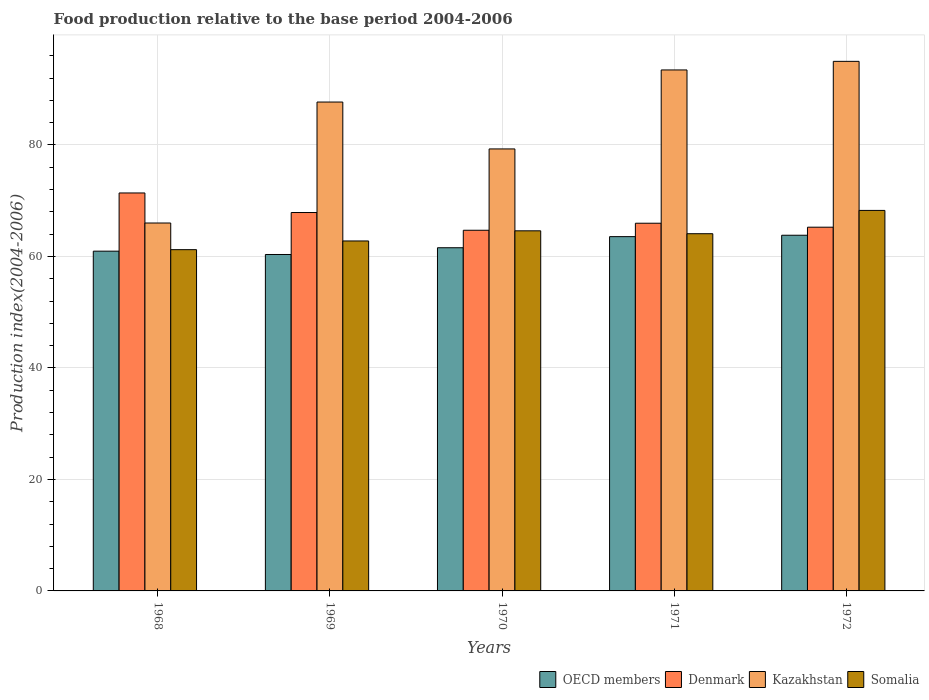How many groups of bars are there?
Offer a very short reply. 5. How many bars are there on the 5th tick from the left?
Offer a terse response. 4. How many bars are there on the 5th tick from the right?
Give a very brief answer. 4. What is the label of the 3rd group of bars from the left?
Your answer should be compact. 1970. In how many cases, is the number of bars for a given year not equal to the number of legend labels?
Make the answer very short. 0. What is the food production index in Somalia in 1970?
Ensure brevity in your answer.  64.6. Across all years, what is the maximum food production index in OECD members?
Ensure brevity in your answer.  63.81. What is the total food production index in OECD members in the graph?
Your response must be concise. 310.23. What is the difference between the food production index in Somalia in 1969 and that in 1970?
Keep it short and to the point. -1.82. What is the difference between the food production index in Denmark in 1968 and the food production index in Kazakhstan in 1972?
Offer a terse response. -23.61. What is the average food production index in Kazakhstan per year?
Give a very brief answer. 84.29. In the year 1968, what is the difference between the food production index in Kazakhstan and food production index in Somalia?
Ensure brevity in your answer.  4.78. In how many years, is the food production index in Somalia greater than 60?
Offer a terse response. 5. What is the ratio of the food production index in Somalia in 1969 to that in 1972?
Offer a terse response. 0.92. Is the difference between the food production index in Kazakhstan in 1969 and 1970 greater than the difference between the food production index in Somalia in 1969 and 1970?
Give a very brief answer. Yes. What is the difference between the highest and the second highest food production index in Kazakhstan?
Keep it short and to the point. 1.54. What is the difference between the highest and the lowest food production index in Somalia?
Your answer should be very brief. 7.04. In how many years, is the food production index in Denmark greater than the average food production index in Denmark taken over all years?
Offer a very short reply. 2. Is the sum of the food production index in Somalia in 1969 and 1970 greater than the maximum food production index in OECD members across all years?
Ensure brevity in your answer.  Yes. Is it the case that in every year, the sum of the food production index in Denmark and food production index in OECD members is greater than the sum of food production index in Somalia and food production index in Kazakhstan?
Offer a very short reply. No. What does the 3rd bar from the left in 1972 represents?
Your answer should be compact. Kazakhstan. What does the 2nd bar from the right in 1971 represents?
Your answer should be very brief. Kazakhstan. How many bars are there?
Ensure brevity in your answer.  20. Are all the bars in the graph horizontal?
Offer a terse response. No. What is the difference between two consecutive major ticks on the Y-axis?
Give a very brief answer. 20. Does the graph contain any zero values?
Your response must be concise. No. Does the graph contain grids?
Provide a succinct answer. Yes. How are the legend labels stacked?
Provide a short and direct response. Horizontal. What is the title of the graph?
Make the answer very short. Food production relative to the base period 2004-2006. Does "Isle of Man" appear as one of the legend labels in the graph?
Make the answer very short. No. What is the label or title of the Y-axis?
Offer a terse response. Production index(2004-2006). What is the Production index(2004-2006) in OECD members in 1968?
Give a very brief answer. 60.95. What is the Production index(2004-2006) in Denmark in 1968?
Provide a succinct answer. 71.39. What is the Production index(2004-2006) in Kazakhstan in 1968?
Your response must be concise. 66. What is the Production index(2004-2006) in Somalia in 1968?
Make the answer very short. 61.22. What is the Production index(2004-2006) in OECD members in 1969?
Give a very brief answer. 60.35. What is the Production index(2004-2006) in Denmark in 1969?
Provide a succinct answer. 67.88. What is the Production index(2004-2006) of Kazakhstan in 1969?
Offer a very short reply. 87.7. What is the Production index(2004-2006) of Somalia in 1969?
Keep it short and to the point. 62.78. What is the Production index(2004-2006) of OECD members in 1970?
Offer a very short reply. 61.56. What is the Production index(2004-2006) of Denmark in 1970?
Keep it short and to the point. 64.7. What is the Production index(2004-2006) in Kazakhstan in 1970?
Keep it short and to the point. 79.29. What is the Production index(2004-2006) in Somalia in 1970?
Make the answer very short. 64.6. What is the Production index(2004-2006) of OECD members in 1971?
Your answer should be very brief. 63.56. What is the Production index(2004-2006) in Denmark in 1971?
Your response must be concise. 65.96. What is the Production index(2004-2006) of Kazakhstan in 1971?
Provide a succinct answer. 93.46. What is the Production index(2004-2006) of Somalia in 1971?
Keep it short and to the point. 64.08. What is the Production index(2004-2006) in OECD members in 1972?
Offer a terse response. 63.81. What is the Production index(2004-2006) in Denmark in 1972?
Provide a succinct answer. 65.25. What is the Production index(2004-2006) in Somalia in 1972?
Offer a terse response. 68.26. Across all years, what is the maximum Production index(2004-2006) in OECD members?
Ensure brevity in your answer.  63.81. Across all years, what is the maximum Production index(2004-2006) in Denmark?
Give a very brief answer. 71.39. Across all years, what is the maximum Production index(2004-2006) in Kazakhstan?
Your answer should be compact. 95. Across all years, what is the maximum Production index(2004-2006) in Somalia?
Your response must be concise. 68.26. Across all years, what is the minimum Production index(2004-2006) of OECD members?
Your answer should be very brief. 60.35. Across all years, what is the minimum Production index(2004-2006) in Denmark?
Give a very brief answer. 64.7. Across all years, what is the minimum Production index(2004-2006) in Somalia?
Ensure brevity in your answer.  61.22. What is the total Production index(2004-2006) of OECD members in the graph?
Your response must be concise. 310.23. What is the total Production index(2004-2006) in Denmark in the graph?
Provide a succinct answer. 335.18. What is the total Production index(2004-2006) in Kazakhstan in the graph?
Your answer should be very brief. 421.45. What is the total Production index(2004-2006) in Somalia in the graph?
Ensure brevity in your answer.  320.94. What is the difference between the Production index(2004-2006) in OECD members in 1968 and that in 1969?
Give a very brief answer. 0.6. What is the difference between the Production index(2004-2006) in Denmark in 1968 and that in 1969?
Offer a terse response. 3.51. What is the difference between the Production index(2004-2006) of Kazakhstan in 1968 and that in 1969?
Provide a succinct answer. -21.7. What is the difference between the Production index(2004-2006) of Somalia in 1968 and that in 1969?
Keep it short and to the point. -1.56. What is the difference between the Production index(2004-2006) of OECD members in 1968 and that in 1970?
Provide a succinct answer. -0.61. What is the difference between the Production index(2004-2006) in Denmark in 1968 and that in 1970?
Give a very brief answer. 6.69. What is the difference between the Production index(2004-2006) in Kazakhstan in 1968 and that in 1970?
Offer a terse response. -13.29. What is the difference between the Production index(2004-2006) of Somalia in 1968 and that in 1970?
Provide a succinct answer. -3.38. What is the difference between the Production index(2004-2006) of OECD members in 1968 and that in 1971?
Your answer should be compact. -2.61. What is the difference between the Production index(2004-2006) in Denmark in 1968 and that in 1971?
Your answer should be very brief. 5.43. What is the difference between the Production index(2004-2006) of Kazakhstan in 1968 and that in 1971?
Provide a short and direct response. -27.46. What is the difference between the Production index(2004-2006) of Somalia in 1968 and that in 1971?
Your answer should be compact. -2.86. What is the difference between the Production index(2004-2006) of OECD members in 1968 and that in 1972?
Make the answer very short. -2.86. What is the difference between the Production index(2004-2006) in Denmark in 1968 and that in 1972?
Your response must be concise. 6.14. What is the difference between the Production index(2004-2006) in Somalia in 1968 and that in 1972?
Make the answer very short. -7.04. What is the difference between the Production index(2004-2006) in OECD members in 1969 and that in 1970?
Offer a very short reply. -1.21. What is the difference between the Production index(2004-2006) of Denmark in 1969 and that in 1970?
Your answer should be compact. 3.18. What is the difference between the Production index(2004-2006) in Kazakhstan in 1969 and that in 1970?
Your response must be concise. 8.41. What is the difference between the Production index(2004-2006) of Somalia in 1969 and that in 1970?
Your answer should be compact. -1.82. What is the difference between the Production index(2004-2006) of OECD members in 1969 and that in 1971?
Give a very brief answer. -3.2. What is the difference between the Production index(2004-2006) of Denmark in 1969 and that in 1971?
Ensure brevity in your answer.  1.92. What is the difference between the Production index(2004-2006) in Kazakhstan in 1969 and that in 1971?
Your answer should be compact. -5.76. What is the difference between the Production index(2004-2006) of OECD members in 1969 and that in 1972?
Provide a short and direct response. -3.45. What is the difference between the Production index(2004-2006) in Denmark in 1969 and that in 1972?
Give a very brief answer. 2.63. What is the difference between the Production index(2004-2006) in Somalia in 1969 and that in 1972?
Keep it short and to the point. -5.48. What is the difference between the Production index(2004-2006) of OECD members in 1970 and that in 1971?
Keep it short and to the point. -1.99. What is the difference between the Production index(2004-2006) in Denmark in 1970 and that in 1971?
Provide a succinct answer. -1.26. What is the difference between the Production index(2004-2006) in Kazakhstan in 1970 and that in 1971?
Keep it short and to the point. -14.17. What is the difference between the Production index(2004-2006) of Somalia in 1970 and that in 1971?
Keep it short and to the point. 0.52. What is the difference between the Production index(2004-2006) in OECD members in 1970 and that in 1972?
Your answer should be compact. -2.24. What is the difference between the Production index(2004-2006) of Denmark in 1970 and that in 1972?
Make the answer very short. -0.55. What is the difference between the Production index(2004-2006) in Kazakhstan in 1970 and that in 1972?
Offer a very short reply. -15.71. What is the difference between the Production index(2004-2006) in Somalia in 1970 and that in 1972?
Make the answer very short. -3.66. What is the difference between the Production index(2004-2006) in OECD members in 1971 and that in 1972?
Provide a short and direct response. -0.25. What is the difference between the Production index(2004-2006) of Denmark in 1971 and that in 1972?
Make the answer very short. 0.71. What is the difference between the Production index(2004-2006) in Kazakhstan in 1971 and that in 1972?
Offer a terse response. -1.54. What is the difference between the Production index(2004-2006) in Somalia in 1971 and that in 1972?
Your response must be concise. -4.18. What is the difference between the Production index(2004-2006) in OECD members in 1968 and the Production index(2004-2006) in Denmark in 1969?
Ensure brevity in your answer.  -6.93. What is the difference between the Production index(2004-2006) in OECD members in 1968 and the Production index(2004-2006) in Kazakhstan in 1969?
Provide a short and direct response. -26.75. What is the difference between the Production index(2004-2006) of OECD members in 1968 and the Production index(2004-2006) of Somalia in 1969?
Your response must be concise. -1.83. What is the difference between the Production index(2004-2006) of Denmark in 1968 and the Production index(2004-2006) of Kazakhstan in 1969?
Provide a short and direct response. -16.31. What is the difference between the Production index(2004-2006) of Denmark in 1968 and the Production index(2004-2006) of Somalia in 1969?
Your response must be concise. 8.61. What is the difference between the Production index(2004-2006) in Kazakhstan in 1968 and the Production index(2004-2006) in Somalia in 1969?
Give a very brief answer. 3.22. What is the difference between the Production index(2004-2006) in OECD members in 1968 and the Production index(2004-2006) in Denmark in 1970?
Your answer should be compact. -3.75. What is the difference between the Production index(2004-2006) in OECD members in 1968 and the Production index(2004-2006) in Kazakhstan in 1970?
Keep it short and to the point. -18.34. What is the difference between the Production index(2004-2006) of OECD members in 1968 and the Production index(2004-2006) of Somalia in 1970?
Offer a terse response. -3.65. What is the difference between the Production index(2004-2006) in Denmark in 1968 and the Production index(2004-2006) in Kazakhstan in 1970?
Give a very brief answer. -7.9. What is the difference between the Production index(2004-2006) in Denmark in 1968 and the Production index(2004-2006) in Somalia in 1970?
Your response must be concise. 6.79. What is the difference between the Production index(2004-2006) in Kazakhstan in 1968 and the Production index(2004-2006) in Somalia in 1970?
Offer a very short reply. 1.4. What is the difference between the Production index(2004-2006) in OECD members in 1968 and the Production index(2004-2006) in Denmark in 1971?
Your answer should be compact. -5.01. What is the difference between the Production index(2004-2006) in OECD members in 1968 and the Production index(2004-2006) in Kazakhstan in 1971?
Ensure brevity in your answer.  -32.51. What is the difference between the Production index(2004-2006) in OECD members in 1968 and the Production index(2004-2006) in Somalia in 1971?
Ensure brevity in your answer.  -3.13. What is the difference between the Production index(2004-2006) in Denmark in 1968 and the Production index(2004-2006) in Kazakhstan in 1971?
Give a very brief answer. -22.07. What is the difference between the Production index(2004-2006) in Denmark in 1968 and the Production index(2004-2006) in Somalia in 1971?
Offer a terse response. 7.31. What is the difference between the Production index(2004-2006) of Kazakhstan in 1968 and the Production index(2004-2006) of Somalia in 1971?
Offer a very short reply. 1.92. What is the difference between the Production index(2004-2006) in OECD members in 1968 and the Production index(2004-2006) in Denmark in 1972?
Your answer should be compact. -4.3. What is the difference between the Production index(2004-2006) of OECD members in 1968 and the Production index(2004-2006) of Kazakhstan in 1972?
Your response must be concise. -34.05. What is the difference between the Production index(2004-2006) of OECD members in 1968 and the Production index(2004-2006) of Somalia in 1972?
Keep it short and to the point. -7.31. What is the difference between the Production index(2004-2006) in Denmark in 1968 and the Production index(2004-2006) in Kazakhstan in 1972?
Offer a terse response. -23.61. What is the difference between the Production index(2004-2006) in Denmark in 1968 and the Production index(2004-2006) in Somalia in 1972?
Provide a succinct answer. 3.13. What is the difference between the Production index(2004-2006) of Kazakhstan in 1968 and the Production index(2004-2006) of Somalia in 1972?
Offer a terse response. -2.26. What is the difference between the Production index(2004-2006) in OECD members in 1969 and the Production index(2004-2006) in Denmark in 1970?
Offer a very short reply. -4.35. What is the difference between the Production index(2004-2006) in OECD members in 1969 and the Production index(2004-2006) in Kazakhstan in 1970?
Your answer should be compact. -18.94. What is the difference between the Production index(2004-2006) of OECD members in 1969 and the Production index(2004-2006) of Somalia in 1970?
Offer a very short reply. -4.25. What is the difference between the Production index(2004-2006) in Denmark in 1969 and the Production index(2004-2006) in Kazakhstan in 1970?
Offer a terse response. -11.41. What is the difference between the Production index(2004-2006) in Denmark in 1969 and the Production index(2004-2006) in Somalia in 1970?
Offer a terse response. 3.28. What is the difference between the Production index(2004-2006) of Kazakhstan in 1969 and the Production index(2004-2006) of Somalia in 1970?
Ensure brevity in your answer.  23.1. What is the difference between the Production index(2004-2006) of OECD members in 1969 and the Production index(2004-2006) of Denmark in 1971?
Keep it short and to the point. -5.61. What is the difference between the Production index(2004-2006) of OECD members in 1969 and the Production index(2004-2006) of Kazakhstan in 1971?
Provide a succinct answer. -33.11. What is the difference between the Production index(2004-2006) in OECD members in 1969 and the Production index(2004-2006) in Somalia in 1971?
Your answer should be compact. -3.73. What is the difference between the Production index(2004-2006) of Denmark in 1969 and the Production index(2004-2006) of Kazakhstan in 1971?
Provide a succinct answer. -25.58. What is the difference between the Production index(2004-2006) of Denmark in 1969 and the Production index(2004-2006) of Somalia in 1971?
Keep it short and to the point. 3.8. What is the difference between the Production index(2004-2006) of Kazakhstan in 1969 and the Production index(2004-2006) of Somalia in 1971?
Provide a short and direct response. 23.62. What is the difference between the Production index(2004-2006) in OECD members in 1969 and the Production index(2004-2006) in Denmark in 1972?
Keep it short and to the point. -4.9. What is the difference between the Production index(2004-2006) of OECD members in 1969 and the Production index(2004-2006) of Kazakhstan in 1972?
Your answer should be very brief. -34.65. What is the difference between the Production index(2004-2006) in OECD members in 1969 and the Production index(2004-2006) in Somalia in 1972?
Your answer should be compact. -7.91. What is the difference between the Production index(2004-2006) of Denmark in 1969 and the Production index(2004-2006) of Kazakhstan in 1972?
Your response must be concise. -27.12. What is the difference between the Production index(2004-2006) of Denmark in 1969 and the Production index(2004-2006) of Somalia in 1972?
Make the answer very short. -0.38. What is the difference between the Production index(2004-2006) of Kazakhstan in 1969 and the Production index(2004-2006) of Somalia in 1972?
Keep it short and to the point. 19.44. What is the difference between the Production index(2004-2006) of OECD members in 1970 and the Production index(2004-2006) of Denmark in 1971?
Your answer should be compact. -4.4. What is the difference between the Production index(2004-2006) in OECD members in 1970 and the Production index(2004-2006) in Kazakhstan in 1971?
Ensure brevity in your answer.  -31.9. What is the difference between the Production index(2004-2006) in OECD members in 1970 and the Production index(2004-2006) in Somalia in 1971?
Your response must be concise. -2.52. What is the difference between the Production index(2004-2006) in Denmark in 1970 and the Production index(2004-2006) in Kazakhstan in 1971?
Give a very brief answer. -28.76. What is the difference between the Production index(2004-2006) in Denmark in 1970 and the Production index(2004-2006) in Somalia in 1971?
Your answer should be very brief. 0.62. What is the difference between the Production index(2004-2006) in Kazakhstan in 1970 and the Production index(2004-2006) in Somalia in 1971?
Make the answer very short. 15.21. What is the difference between the Production index(2004-2006) of OECD members in 1970 and the Production index(2004-2006) of Denmark in 1972?
Offer a terse response. -3.69. What is the difference between the Production index(2004-2006) in OECD members in 1970 and the Production index(2004-2006) in Kazakhstan in 1972?
Provide a succinct answer. -33.44. What is the difference between the Production index(2004-2006) in OECD members in 1970 and the Production index(2004-2006) in Somalia in 1972?
Your answer should be very brief. -6.7. What is the difference between the Production index(2004-2006) of Denmark in 1970 and the Production index(2004-2006) of Kazakhstan in 1972?
Make the answer very short. -30.3. What is the difference between the Production index(2004-2006) of Denmark in 1970 and the Production index(2004-2006) of Somalia in 1972?
Your answer should be compact. -3.56. What is the difference between the Production index(2004-2006) in Kazakhstan in 1970 and the Production index(2004-2006) in Somalia in 1972?
Make the answer very short. 11.03. What is the difference between the Production index(2004-2006) in OECD members in 1971 and the Production index(2004-2006) in Denmark in 1972?
Keep it short and to the point. -1.69. What is the difference between the Production index(2004-2006) in OECD members in 1971 and the Production index(2004-2006) in Kazakhstan in 1972?
Your answer should be compact. -31.44. What is the difference between the Production index(2004-2006) in OECD members in 1971 and the Production index(2004-2006) in Somalia in 1972?
Keep it short and to the point. -4.7. What is the difference between the Production index(2004-2006) in Denmark in 1971 and the Production index(2004-2006) in Kazakhstan in 1972?
Your answer should be compact. -29.04. What is the difference between the Production index(2004-2006) in Denmark in 1971 and the Production index(2004-2006) in Somalia in 1972?
Your answer should be very brief. -2.3. What is the difference between the Production index(2004-2006) of Kazakhstan in 1971 and the Production index(2004-2006) of Somalia in 1972?
Your response must be concise. 25.2. What is the average Production index(2004-2006) in OECD members per year?
Provide a succinct answer. 62.05. What is the average Production index(2004-2006) of Denmark per year?
Offer a terse response. 67.04. What is the average Production index(2004-2006) in Kazakhstan per year?
Your answer should be very brief. 84.29. What is the average Production index(2004-2006) in Somalia per year?
Your response must be concise. 64.19. In the year 1968, what is the difference between the Production index(2004-2006) in OECD members and Production index(2004-2006) in Denmark?
Your answer should be compact. -10.44. In the year 1968, what is the difference between the Production index(2004-2006) in OECD members and Production index(2004-2006) in Kazakhstan?
Give a very brief answer. -5.05. In the year 1968, what is the difference between the Production index(2004-2006) of OECD members and Production index(2004-2006) of Somalia?
Your response must be concise. -0.27. In the year 1968, what is the difference between the Production index(2004-2006) in Denmark and Production index(2004-2006) in Kazakhstan?
Make the answer very short. 5.39. In the year 1968, what is the difference between the Production index(2004-2006) of Denmark and Production index(2004-2006) of Somalia?
Give a very brief answer. 10.17. In the year 1968, what is the difference between the Production index(2004-2006) of Kazakhstan and Production index(2004-2006) of Somalia?
Make the answer very short. 4.78. In the year 1969, what is the difference between the Production index(2004-2006) in OECD members and Production index(2004-2006) in Denmark?
Provide a short and direct response. -7.53. In the year 1969, what is the difference between the Production index(2004-2006) of OECD members and Production index(2004-2006) of Kazakhstan?
Keep it short and to the point. -27.35. In the year 1969, what is the difference between the Production index(2004-2006) of OECD members and Production index(2004-2006) of Somalia?
Your response must be concise. -2.43. In the year 1969, what is the difference between the Production index(2004-2006) of Denmark and Production index(2004-2006) of Kazakhstan?
Keep it short and to the point. -19.82. In the year 1969, what is the difference between the Production index(2004-2006) in Denmark and Production index(2004-2006) in Somalia?
Ensure brevity in your answer.  5.1. In the year 1969, what is the difference between the Production index(2004-2006) of Kazakhstan and Production index(2004-2006) of Somalia?
Your answer should be compact. 24.92. In the year 1970, what is the difference between the Production index(2004-2006) of OECD members and Production index(2004-2006) of Denmark?
Provide a short and direct response. -3.14. In the year 1970, what is the difference between the Production index(2004-2006) in OECD members and Production index(2004-2006) in Kazakhstan?
Your response must be concise. -17.73. In the year 1970, what is the difference between the Production index(2004-2006) in OECD members and Production index(2004-2006) in Somalia?
Your response must be concise. -3.04. In the year 1970, what is the difference between the Production index(2004-2006) of Denmark and Production index(2004-2006) of Kazakhstan?
Make the answer very short. -14.59. In the year 1970, what is the difference between the Production index(2004-2006) in Kazakhstan and Production index(2004-2006) in Somalia?
Ensure brevity in your answer.  14.69. In the year 1971, what is the difference between the Production index(2004-2006) of OECD members and Production index(2004-2006) of Denmark?
Make the answer very short. -2.4. In the year 1971, what is the difference between the Production index(2004-2006) in OECD members and Production index(2004-2006) in Kazakhstan?
Offer a very short reply. -29.9. In the year 1971, what is the difference between the Production index(2004-2006) in OECD members and Production index(2004-2006) in Somalia?
Give a very brief answer. -0.52. In the year 1971, what is the difference between the Production index(2004-2006) in Denmark and Production index(2004-2006) in Kazakhstan?
Provide a short and direct response. -27.5. In the year 1971, what is the difference between the Production index(2004-2006) in Denmark and Production index(2004-2006) in Somalia?
Your response must be concise. 1.88. In the year 1971, what is the difference between the Production index(2004-2006) of Kazakhstan and Production index(2004-2006) of Somalia?
Ensure brevity in your answer.  29.38. In the year 1972, what is the difference between the Production index(2004-2006) of OECD members and Production index(2004-2006) of Denmark?
Provide a short and direct response. -1.44. In the year 1972, what is the difference between the Production index(2004-2006) of OECD members and Production index(2004-2006) of Kazakhstan?
Provide a succinct answer. -31.19. In the year 1972, what is the difference between the Production index(2004-2006) of OECD members and Production index(2004-2006) of Somalia?
Make the answer very short. -4.45. In the year 1972, what is the difference between the Production index(2004-2006) of Denmark and Production index(2004-2006) of Kazakhstan?
Your response must be concise. -29.75. In the year 1972, what is the difference between the Production index(2004-2006) in Denmark and Production index(2004-2006) in Somalia?
Your answer should be very brief. -3.01. In the year 1972, what is the difference between the Production index(2004-2006) of Kazakhstan and Production index(2004-2006) of Somalia?
Your response must be concise. 26.74. What is the ratio of the Production index(2004-2006) in OECD members in 1968 to that in 1969?
Provide a short and direct response. 1.01. What is the ratio of the Production index(2004-2006) of Denmark in 1968 to that in 1969?
Make the answer very short. 1.05. What is the ratio of the Production index(2004-2006) in Kazakhstan in 1968 to that in 1969?
Your answer should be compact. 0.75. What is the ratio of the Production index(2004-2006) in Somalia in 1968 to that in 1969?
Ensure brevity in your answer.  0.98. What is the ratio of the Production index(2004-2006) in Denmark in 1968 to that in 1970?
Make the answer very short. 1.1. What is the ratio of the Production index(2004-2006) in Kazakhstan in 1968 to that in 1970?
Provide a short and direct response. 0.83. What is the ratio of the Production index(2004-2006) in Somalia in 1968 to that in 1970?
Your answer should be very brief. 0.95. What is the ratio of the Production index(2004-2006) in Denmark in 1968 to that in 1971?
Provide a succinct answer. 1.08. What is the ratio of the Production index(2004-2006) in Kazakhstan in 1968 to that in 1971?
Make the answer very short. 0.71. What is the ratio of the Production index(2004-2006) in Somalia in 1968 to that in 1971?
Provide a short and direct response. 0.96. What is the ratio of the Production index(2004-2006) in OECD members in 1968 to that in 1972?
Make the answer very short. 0.96. What is the ratio of the Production index(2004-2006) in Denmark in 1968 to that in 1972?
Your answer should be very brief. 1.09. What is the ratio of the Production index(2004-2006) in Kazakhstan in 1968 to that in 1972?
Offer a terse response. 0.69. What is the ratio of the Production index(2004-2006) of Somalia in 1968 to that in 1972?
Provide a succinct answer. 0.9. What is the ratio of the Production index(2004-2006) of OECD members in 1969 to that in 1970?
Give a very brief answer. 0.98. What is the ratio of the Production index(2004-2006) of Denmark in 1969 to that in 1970?
Keep it short and to the point. 1.05. What is the ratio of the Production index(2004-2006) in Kazakhstan in 1969 to that in 1970?
Your answer should be compact. 1.11. What is the ratio of the Production index(2004-2006) in Somalia in 1969 to that in 1970?
Make the answer very short. 0.97. What is the ratio of the Production index(2004-2006) of OECD members in 1969 to that in 1971?
Your answer should be very brief. 0.95. What is the ratio of the Production index(2004-2006) in Denmark in 1969 to that in 1971?
Keep it short and to the point. 1.03. What is the ratio of the Production index(2004-2006) in Kazakhstan in 1969 to that in 1971?
Give a very brief answer. 0.94. What is the ratio of the Production index(2004-2006) in Somalia in 1969 to that in 1971?
Give a very brief answer. 0.98. What is the ratio of the Production index(2004-2006) of OECD members in 1969 to that in 1972?
Make the answer very short. 0.95. What is the ratio of the Production index(2004-2006) of Denmark in 1969 to that in 1972?
Offer a very short reply. 1.04. What is the ratio of the Production index(2004-2006) in Kazakhstan in 1969 to that in 1972?
Your response must be concise. 0.92. What is the ratio of the Production index(2004-2006) in Somalia in 1969 to that in 1972?
Ensure brevity in your answer.  0.92. What is the ratio of the Production index(2004-2006) in OECD members in 1970 to that in 1971?
Your answer should be compact. 0.97. What is the ratio of the Production index(2004-2006) of Denmark in 1970 to that in 1971?
Provide a short and direct response. 0.98. What is the ratio of the Production index(2004-2006) of Kazakhstan in 1970 to that in 1971?
Provide a succinct answer. 0.85. What is the ratio of the Production index(2004-2006) in OECD members in 1970 to that in 1972?
Make the answer very short. 0.96. What is the ratio of the Production index(2004-2006) of Denmark in 1970 to that in 1972?
Give a very brief answer. 0.99. What is the ratio of the Production index(2004-2006) in Kazakhstan in 1970 to that in 1972?
Give a very brief answer. 0.83. What is the ratio of the Production index(2004-2006) in Somalia in 1970 to that in 1972?
Provide a short and direct response. 0.95. What is the ratio of the Production index(2004-2006) in OECD members in 1971 to that in 1972?
Your response must be concise. 1. What is the ratio of the Production index(2004-2006) of Denmark in 1971 to that in 1972?
Your answer should be very brief. 1.01. What is the ratio of the Production index(2004-2006) in Kazakhstan in 1971 to that in 1972?
Your answer should be very brief. 0.98. What is the ratio of the Production index(2004-2006) in Somalia in 1971 to that in 1972?
Your response must be concise. 0.94. What is the difference between the highest and the second highest Production index(2004-2006) of OECD members?
Offer a very short reply. 0.25. What is the difference between the highest and the second highest Production index(2004-2006) in Denmark?
Your answer should be very brief. 3.51. What is the difference between the highest and the second highest Production index(2004-2006) of Kazakhstan?
Keep it short and to the point. 1.54. What is the difference between the highest and the second highest Production index(2004-2006) of Somalia?
Provide a short and direct response. 3.66. What is the difference between the highest and the lowest Production index(2004-2006) in OECD members?
Your answer should be very brief. 3.45. What is the difference between the highest and the lowest Production index(2004-2006) of Denmark?
Make the answer very short. 6.69. What is the difference between the highest and the lowest Production index(2004-2006) of Kazakhstan?
Keep it short and to the point. 29. What is the difference between the highest and the lowest Production index(2004-2006) of Somalia?
Make the answer very short. 7.04. 